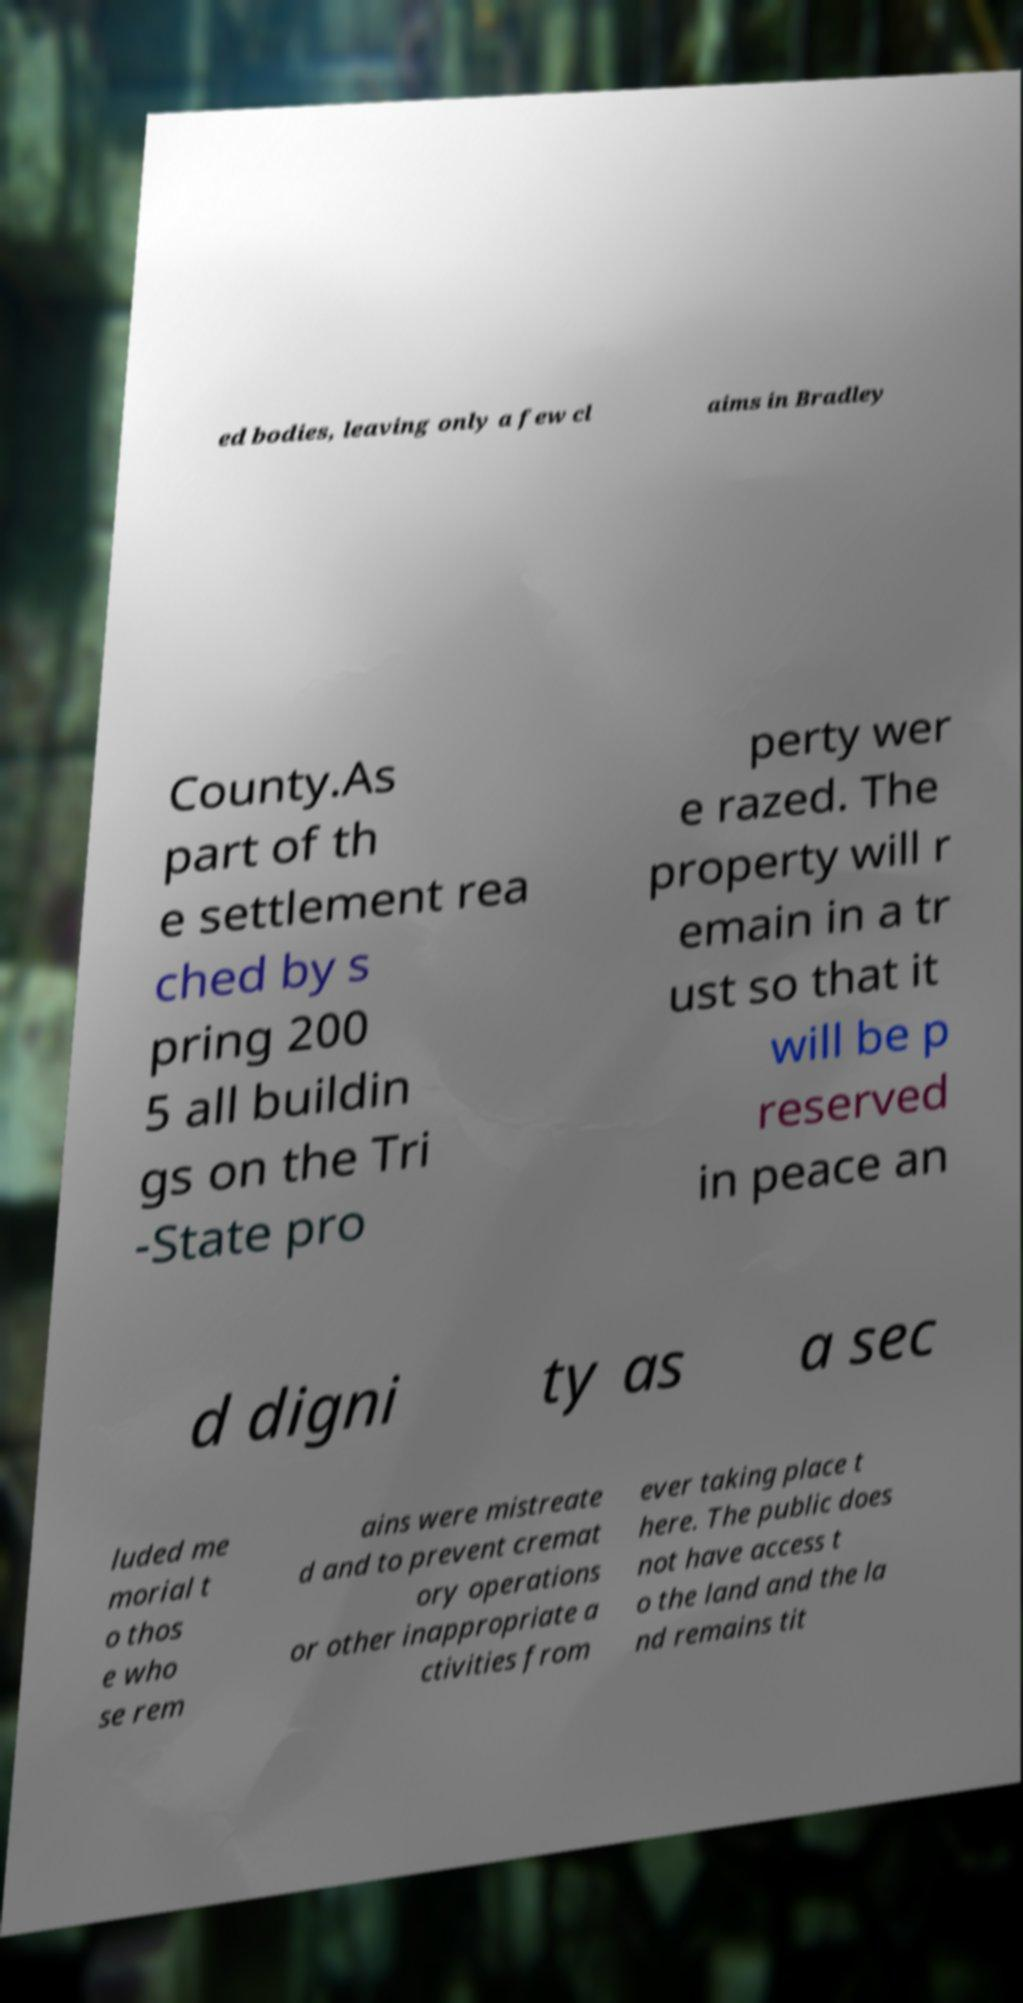Could you assist in decoding the text presented in this image and type it out clearly? ed bodies, leaving only a few cl aims in Bradley County.As part of th e settlement rea ched by s pring 200 5 all buildin gs on the Tri -State pro perty wer e razed. The property will r emain in a tr ust so that it will be p reserved in peace an d digni ty as a sec luded me morial t o thos e who se rem ains were mistreate d and to prevent cremat ory operations or other inappropriate a ctivities from ever taking place t here. The public does not have access t o the land and the la nd remains tit 